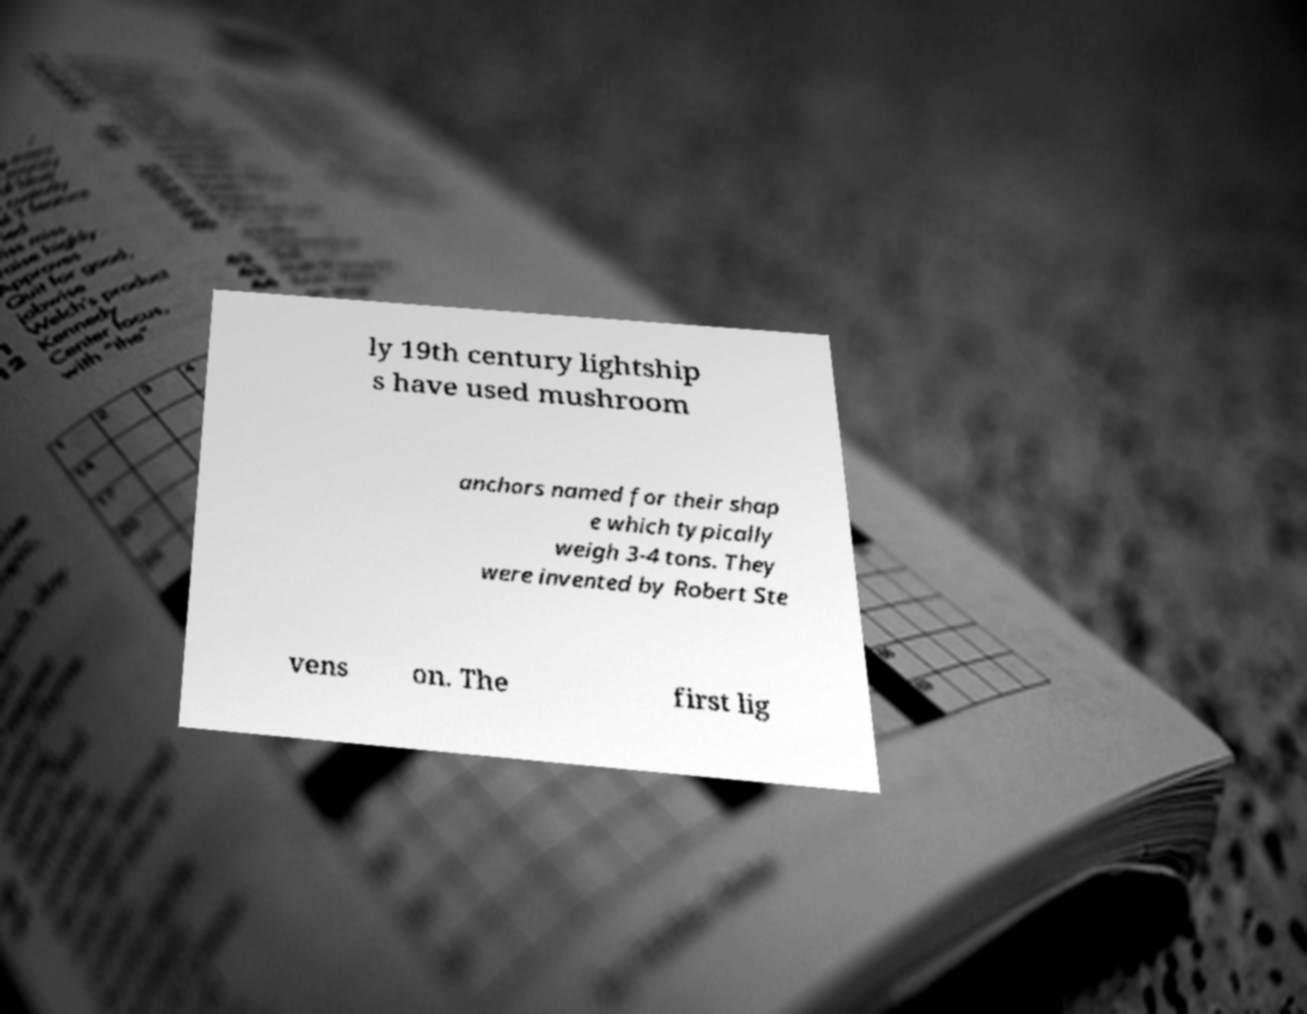Please read and relay the text visible in this image. What does it say? ly 19th century lightship s have used mushroom anchors named for their shap e which typically weigh 3-4 tons. They were invented by Robert Ste vens on. The first lig 